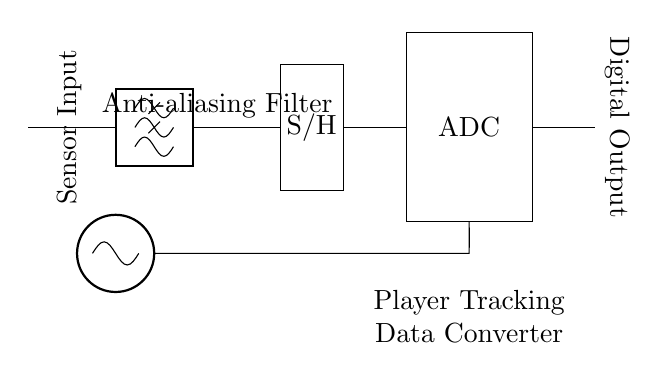What is the first component in the circuit? The first component in the circuit is the sensor input, which is connected to the circuit and acts as the initial point for capturing raw tracking data.
Answer: Sensor Input What type of filter is used in the circuit? The circuit uses a lowpass filter, specifically an anti-aliasing filter, which serves to remove high-frequency noise from the sensor signals before sampling them.
Answer: Anti-aliasing Filter How many main stages are there in the circuit? The circuit has three main stages: the anti-aliasing filter, sample and hold, and the ADC. Each stage processes the signal to convert raw data into a digital format.
Answer: Three What component provides the clock signal? The component that provides the clock signal is an oscillator, which is essential for timing coordination during the analog-to-digital conversion process.
Answer: Oscillator What is the output of the ADC? The output of the ADC (Analog-to-Digital Converter) is a digital output, which represents the converted data from the analog signals received from the previous stages.
Answer: Digital Output Which component is positioned at the bottom of the diagram? The component at the bottom of the diagram is the clock signal, denoted by the oscillator, which typically appears lower in the schematic to indicate its supportive role in timing.
Answer: CLK 